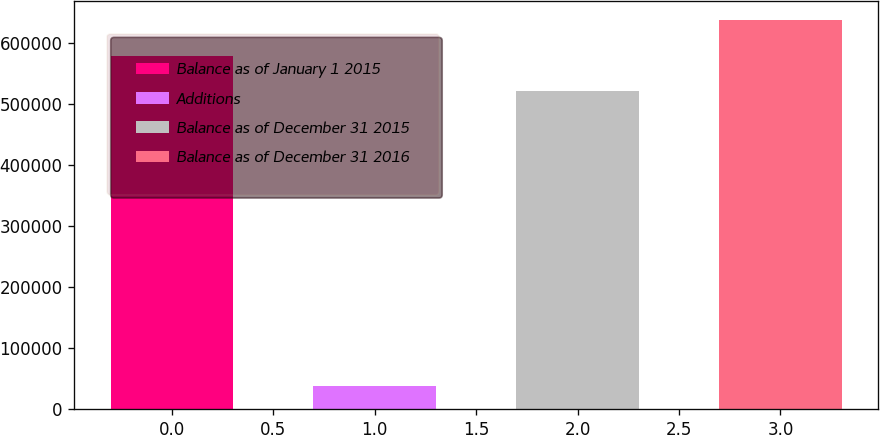<chart> <loc_0><loc_0><loc_500><loc_500><bar_chart><fcel>Balance as of January 1 2015<fcel>Additions<fcel>Balance as of December 31 2015<fcel>Balance as of December 31 2016<nl><fcel>579204<fcel>38596<fcel>521213<fcel>637196<nl></chart> 